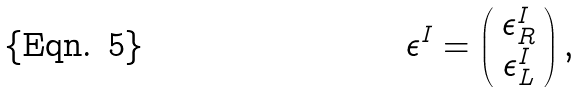Convert formula to latex. <formula><loc_0><loc_0><loc_500><loc_500>\epsilon ^ { I } = \left ( \begin{array} { c } \epsilon ^ { I } _ { R } \\ \epsilon ^ { I } _ { L } \end{array} \right ) ,</formula> 